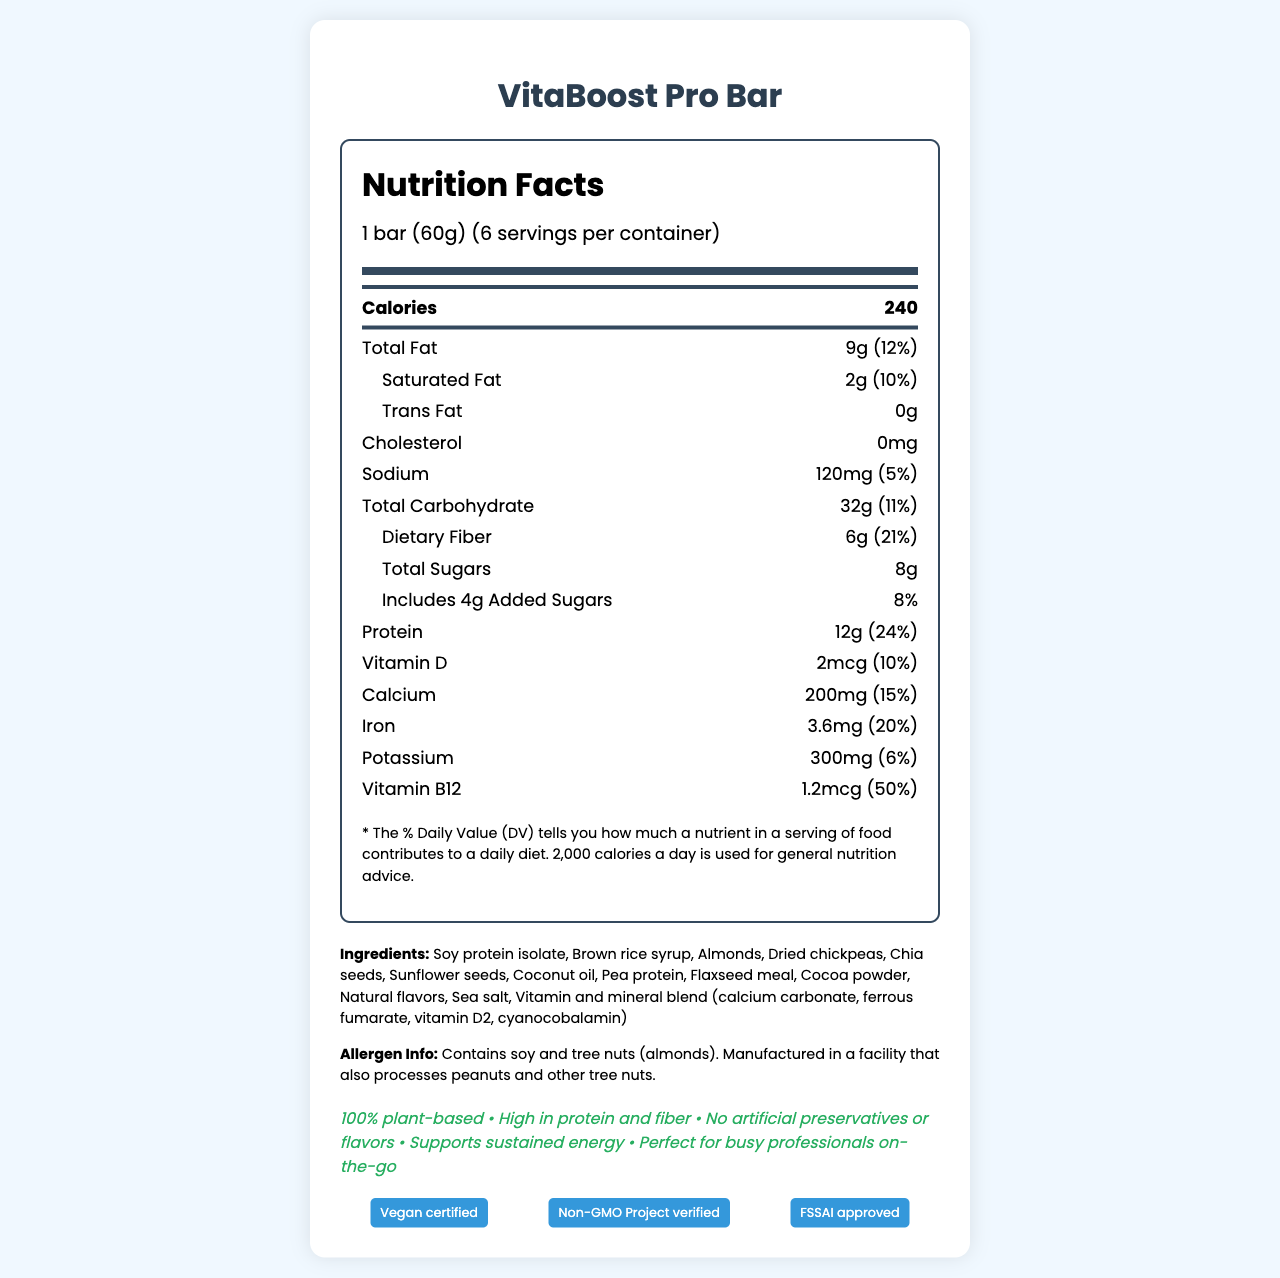Who manufactures the VitaBoost Pro Bar? The document specifies the manufacturer as HealthyBites Nutrition Pvt. Ltd., located in Mumbai, India.
Answer: HealthyBites Nutrition Pvt. Ltd., Mumbai, India What is the serving size of the VitaBoost Pro Bar? The serving size is mentioned as 1 bar, which weighs 60 grams.
Answer: 1 bar (60g) How many calories are in one serving of the VitaBoost Pro Bar? The document lists 240 calories per serving.
Answer: 240 Which ingredient is NOT included in the VitaBoost Pro Bar? A. Almonds B. Pea protein C. Honey D. Cocoa powder Honey is not listed among the ingredients. The other options (Almonds, Pea protein, and Cocoa powder) are included.
Answer: C. Honey How much protein does one bar contain? The document states that one bar contains 12g of protein.
Answer: 12g Is the VitaBoost Pro Bar vegan certified? According to the document, it is vegan certified.
Answer: Yes What is the percentage of the daily value of calcium in one bar? The document shows that one bar contains 15% of the daily value of calcium.
Answer: 15% What is the main source of protein in the VitaBoost Pro Bar? Soy protein isolate is listed as one of the main ingredients and is a significant source of protein.
Answer: Soy protein isolate Which of the following is NOT a marketing claim of the VitaBoost Pro Bar? A. Gluten-Free B. 100% plant-based C. High in protein and fiber D. No artificial preservatives or flavors The marketing claims do not mention that the bar is gluten-free.
Answer: A. Gluten-Free How many grams of dietary fiber are in each serving? The dietary fiber content per serving is 6g as stated in the document.
Answer: 6g Does the VitaBoost Pro Bar contain any cholesterol? The document mentions that the bar contains 0mg of cholesterol.
Answer: No Summarize the main details of the VitaBoost Pro Bar's nutrition and other claims. The description highlights the nutritional benefits, main ingredients, and key marketing and certification claims of the bar.
Answer: The VitaBoost Pro Bar is a 60g vegetarian meal replacement bar high in protein and fiber, containing 240 calories per serving, with significant amounts of vitamins and minerals like calcium, iron, and vitamin B12. It has 9g of total fat, including 2g of saturated fat, and contains no cholesterol or trans fats. Key ingredients include soy protein isolate, almond, chia seeds, and a vitamin/mineral blend. Marketed for being 100% plant-based with no artificial preservatives, it's vegan certified, Non-GMO Project verified, and FSSAI approved. There are allergen warnings for soy and tree nuts. What is the customer care contact email provided in the document? The document provides the customer care email as care@healthybites.in.
Answer: care@healthybites.in Can the document tell us whether the product is diabetic-friendly? The document does not provide specific information about whether the product is suitable for people with diabetes.
Answer: Cannot be determined 